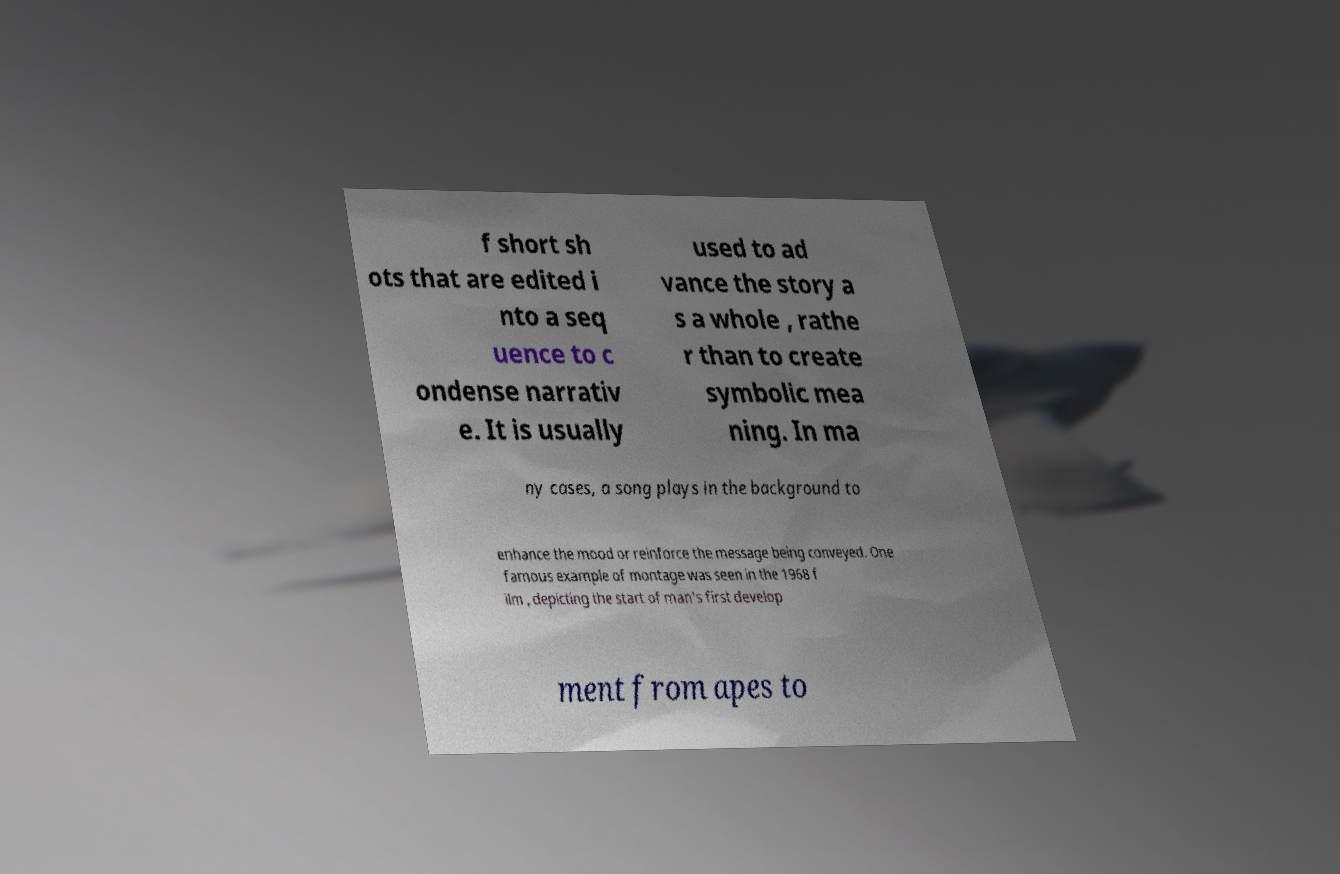What messages or text are displayed in this image? I need them in a readable, typed format. f short sh ots that are edited i nto a seq uence to c ondense narrativ e. It is usually used to ad vance the story a s a whole , rathe r than to create symbolic mea ning. In ma ny cases, a song plays in the background to enhance the mood or reinforce the message being conveyed. One famous example of montage was seen in the 1968 f ilm , depicting the start of man's first develop ment from apes to 